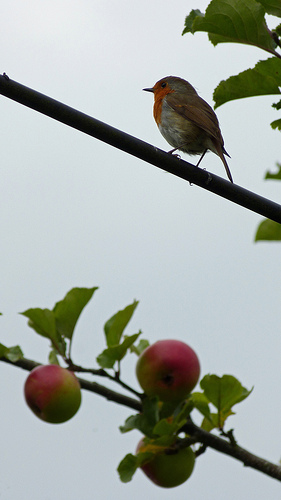Is there any cultural significance to the scene in this image? This tranquil scene of the robin amidst nature is reminiscent of pastoral imagery that celebrates the calm and beauty of the countryside. Robins are also culturally significant in many societies, often symbolizing rebirth or the coming of spring. 